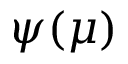<formula> <loc_0><loc_0><loc_500><loc_500>\psi ( \mu )</formula> 